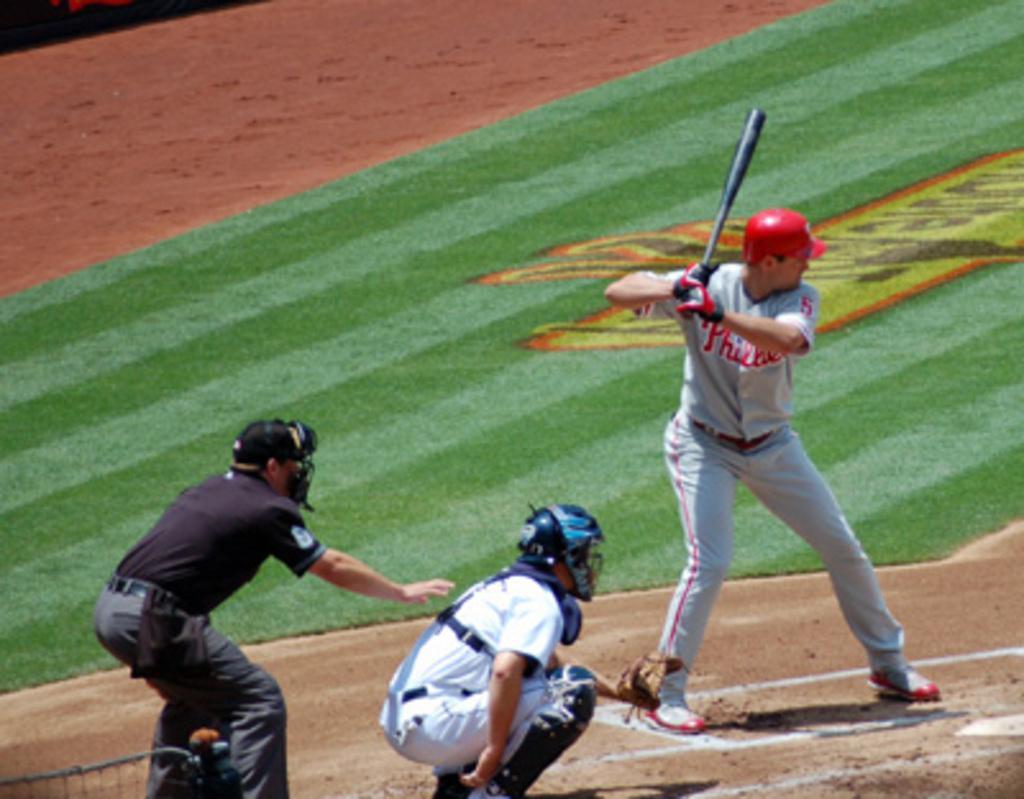In one or two sentences, can you explain what this image depicts? This image is taken outdoors. At the bottom of the image there is a ground with grass on it. On the left side of the image a man is fielding on the ground. In the middle of the image a man is in a squatting position. On the right side of the image a man is standing and playing baseball with a baseball bat. 